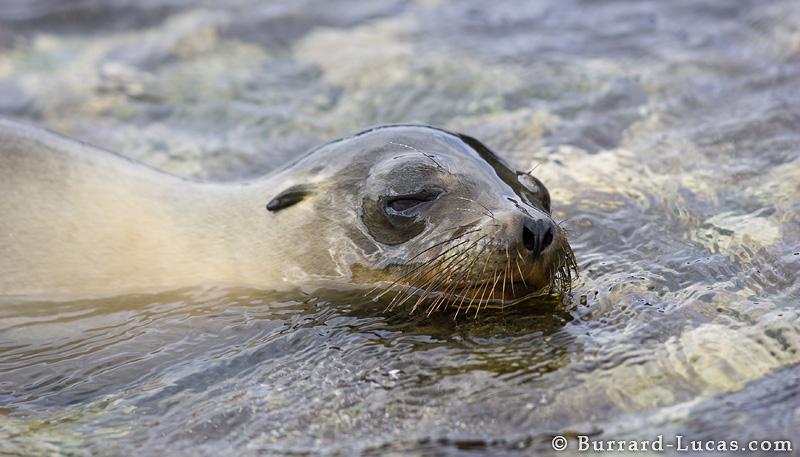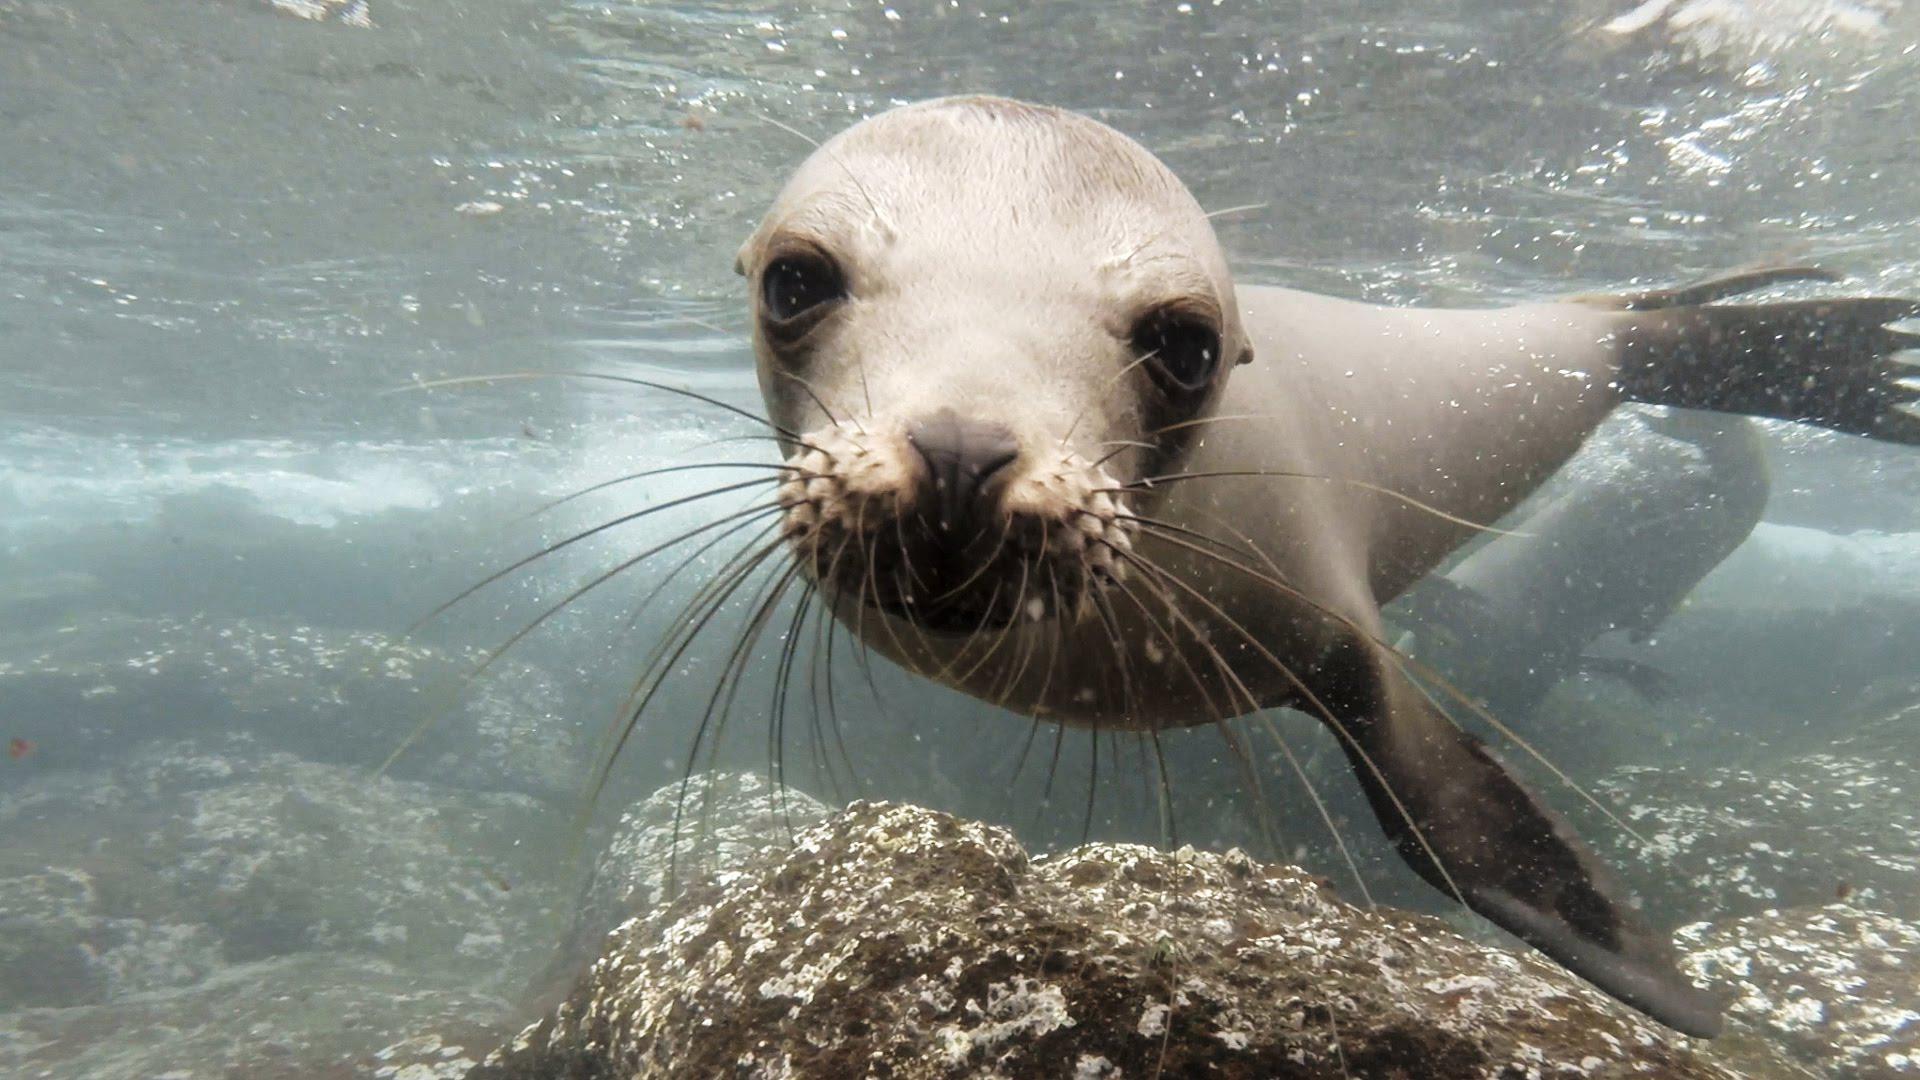The first image is the image on the left, the second image is the image on the right. Assess this claim about the two images: "A single seal is standing on top of a rock with its mouth open.". Correct or not? Answer yes or no. No. The first image is the image on the left, the second image is the image on the right. For the images shown, is this caption "One seal has its mouth open, and another one does not." true? Answer yes or no. No. 